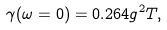<formula> <loc_0><loc_0><loc_500><loc_500>\gamma ( \omega = 0 ) = 0 . 2 6 4 g ^ { 2 } T ,</formula> 